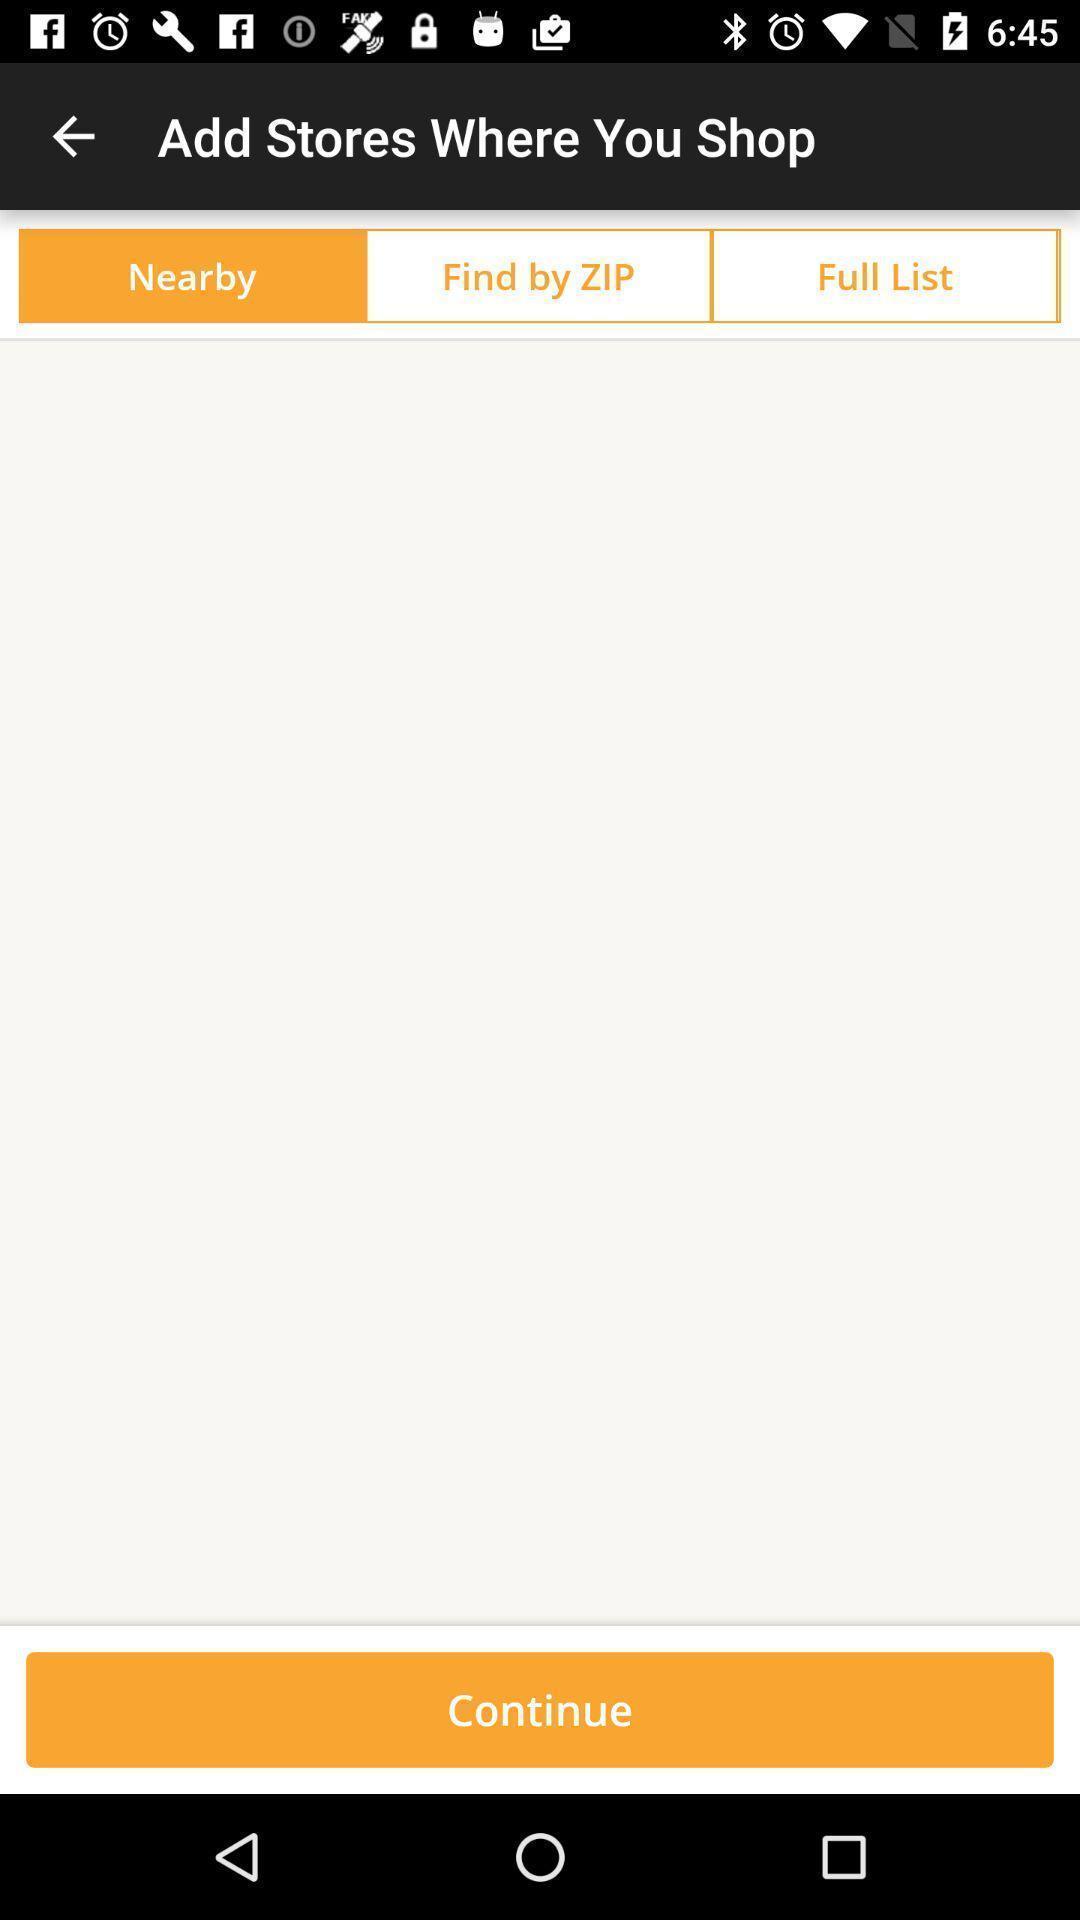Provide a textual representation of this image. Page displaying various options to find the stores in application. 